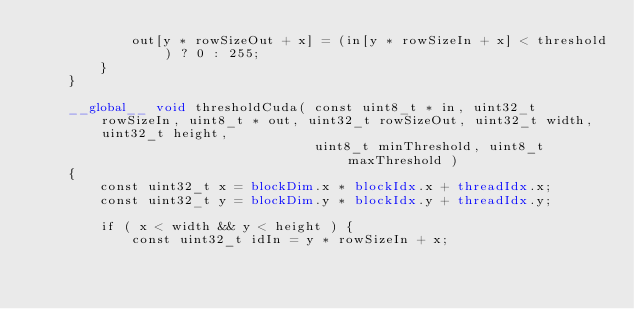Convert code to text. <code><loc_0><loc_0><loc_500><loc_500><_Cuda_>            out[y * rowSizeOut + x] = (in[y * rowSizeIn + x] < threshold) ? 0 : 255;
        }
    }

    __global__ void thresholdCuda( const uint8_t * in, uint32_t rowSizeIn, uint8_t * out, uint32_t rowSizeOut, uint32_t width, uint32_t height,
                                   uint8_t minThreshold, uint8_t maxThreshold )
    {
        const uint32_t x = blockDim.x * blockIdx.x + threadIdx.x;
        const uint32_t y = blockDim.y * blockIdx.y + threadIdx.y;

        if ( x < width && y < height ) {
            const uint32_t idIn = y * rowSizeIn + x;</code> 